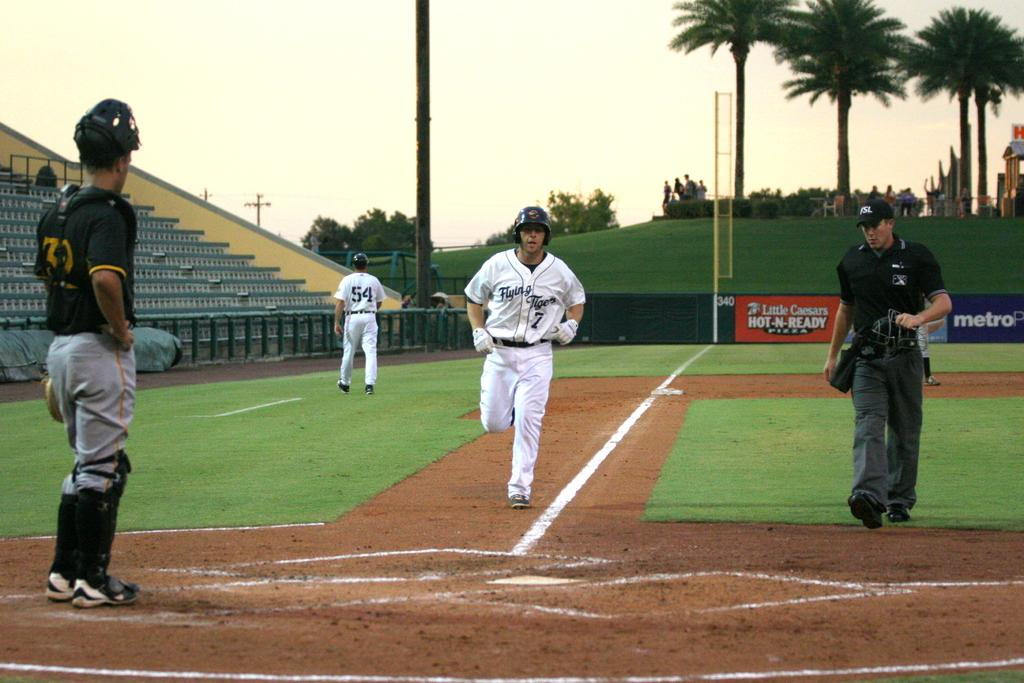<image>
Give a short and clear explanation of the subsequent image. a player rounding third base has the word flying on his jersey 